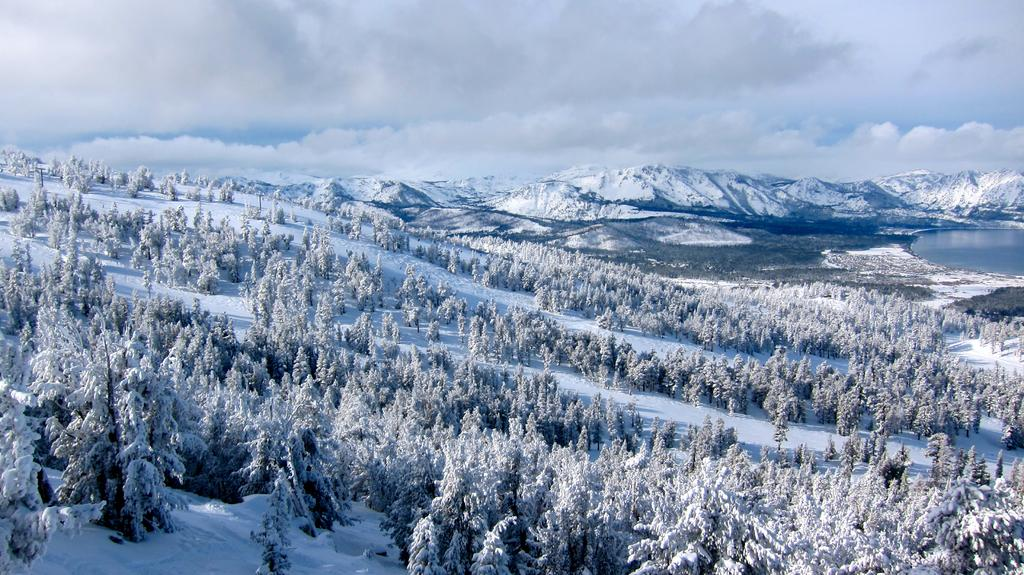What type of landscape is depicted in the image? The image shows a snowy landscape with many trees. What geographical features can be seen in the image? There are mountains visible in the image. Is there any body of water present in the image? Yes, there is a water body in the image. What is the condition of the sky in the image? The sky is covered with clouds. How many degrees does the hen have in the image? There is no hen present in the image, so it is not possible to determine the number of degrees it might have. 